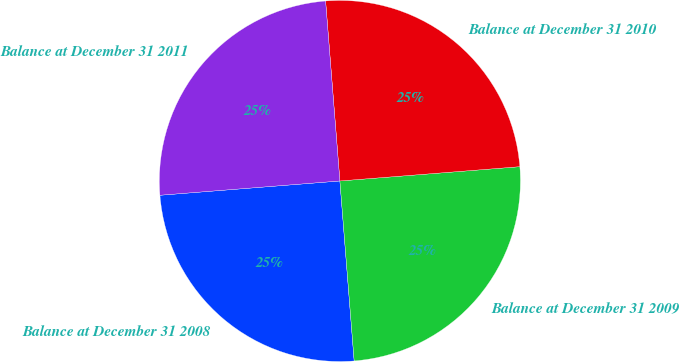Convert chart to OTSL. <chart><loc_0><loc_0><loc_500><loc_500><pie_chart><fcel>Balance at December 31 2008<fcel>Balance at December 31 2009<fcel>Balance at December 31 2010<fcel>Balance at December 31 2011<nl><fcel>25.0%<fcel>25.0%<fcel>25.0%<fcel>25.0%<nl></chart> 